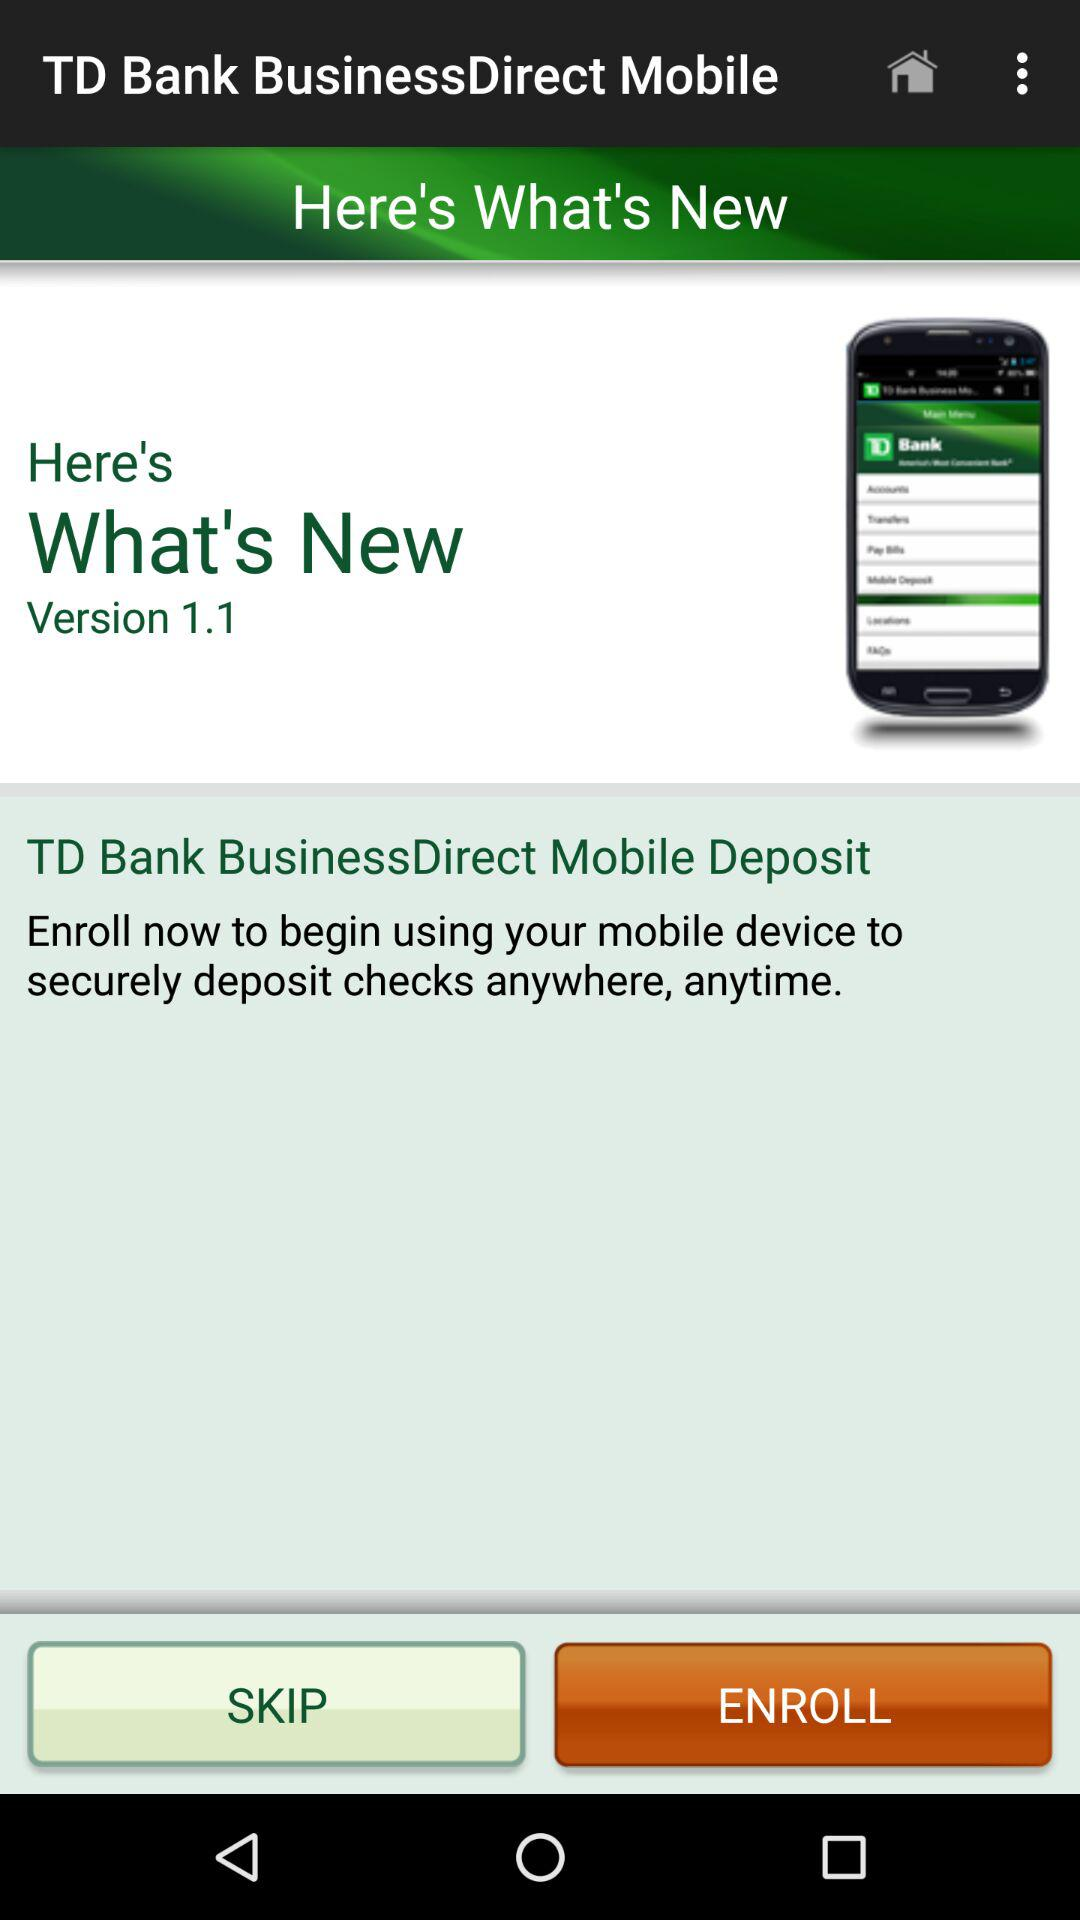What is the name of the application? The name of the application is "TD Bank BusinessDirect Mobile". 